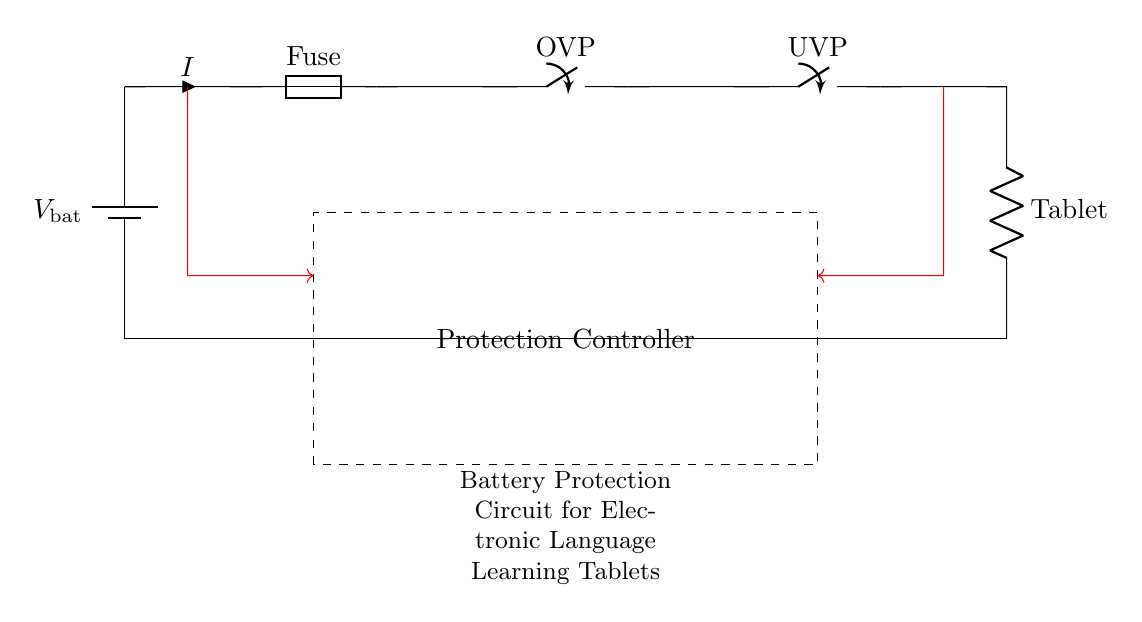What type of protection is included in the circuit? The circuit includes overcurrent protection, overvoltage protection, and undervoltage protection, which are indicated by the respective components labeled as Fuse, OVP, and UVP.
Answer: Overcurrent, Overvoltage, Undervoltage What does the fuse do? The fuse is a component that provides overcurrent protection by breaking the circuit if the current exceeds a certain level. It is located after the battery and before the overvoltage protection.
Answer: Breaks the circuit What component is used to indicate the load in this circuit? The load in this circuit is represented by the resistor labeled 'Tablet', which draws power from the battery after the protection mechanisms.
Answer: Tablet How does the undervoltage protection function in the circuit? The undervoltage protection is represented by a closing switch labeled UVP, which disconnects the load if the battery voltage falls below a defined level, thus preventing damage.
Answer: Disconnects load What is the function of the protection controller in the circuit? The protection controller monitors the conditions of the battery voltage and current, and it operates the switches for the overvoltage and undervoltage protections based on the sensed data.
Answer: Monitors conditions 